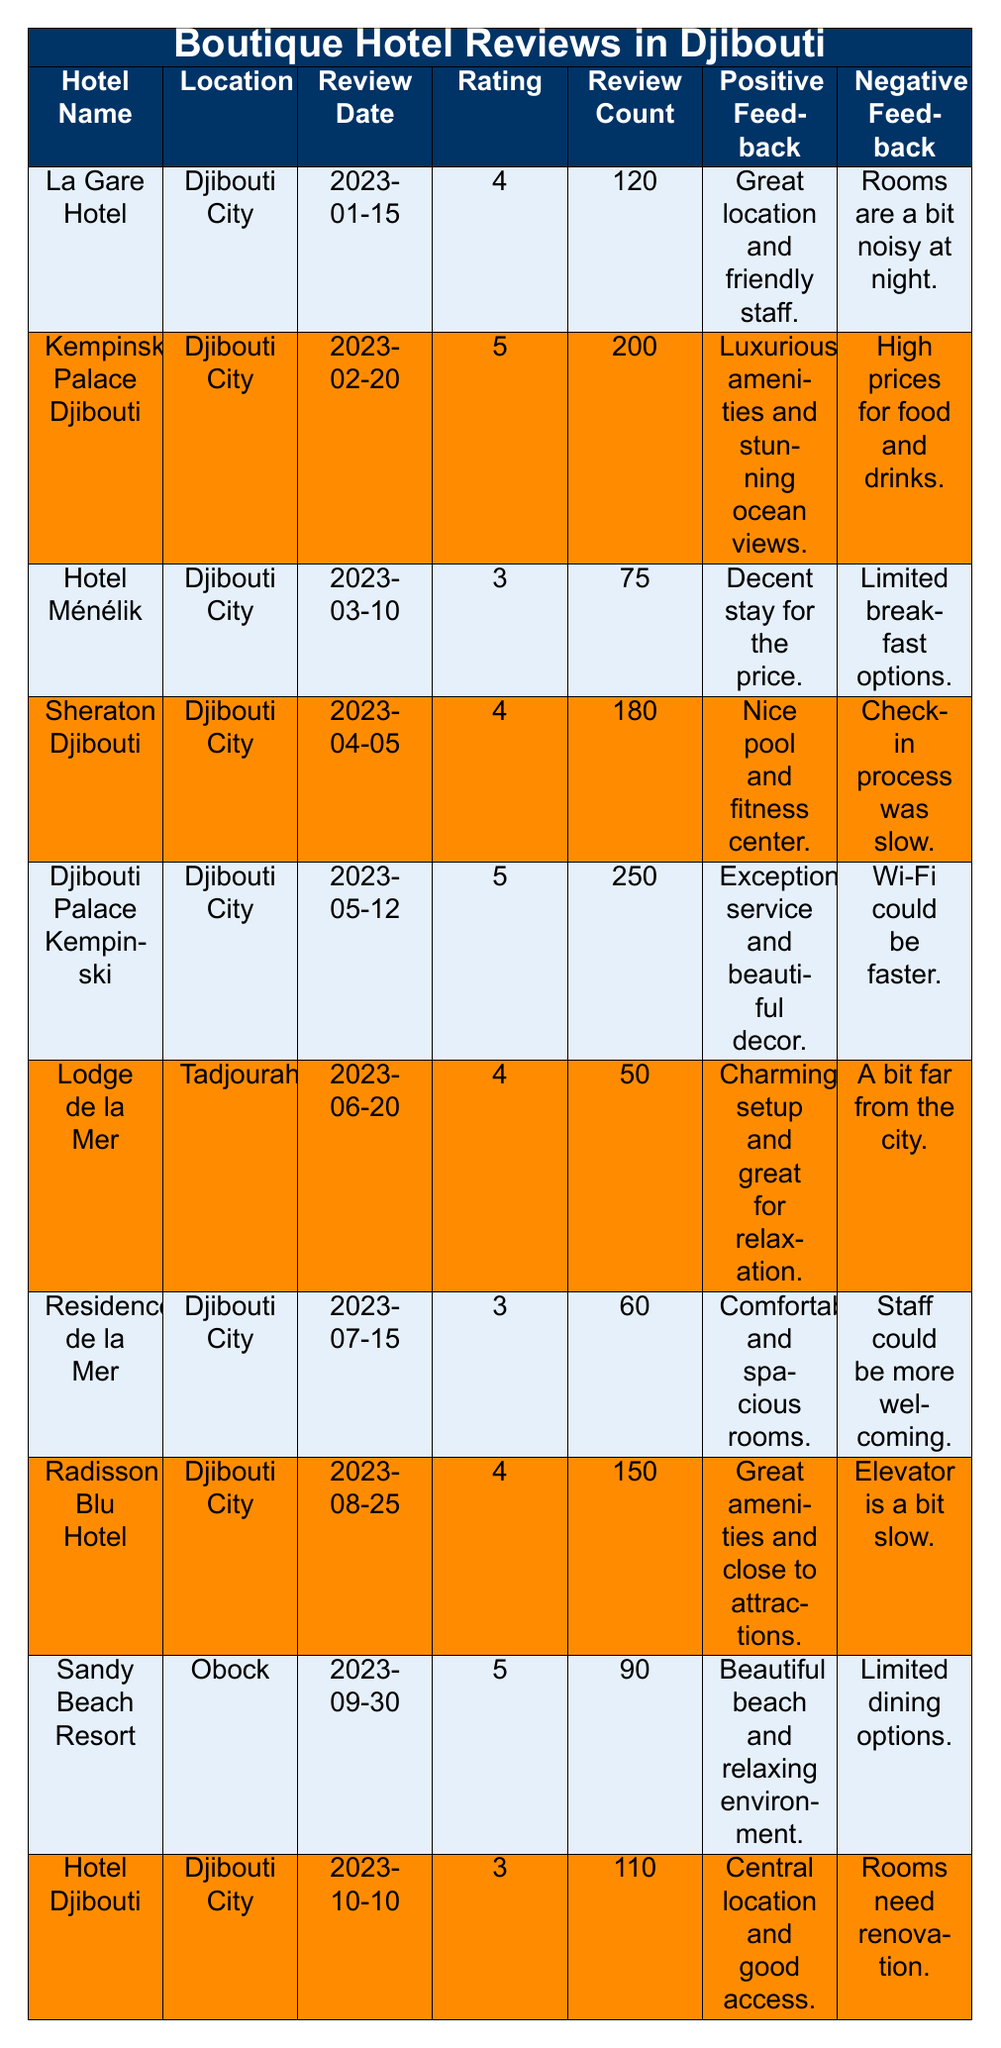What is the highest review rating among the hotels listed? The highest rating in the table is 5, which can be found next to "Kempinski Palace Djibouti", "Djibouti Palace Kempinski", and "Sandy Beach Resort".
Answer: 5 Which hotel received the most reviews? "Djibouti Palace Kempinski" has the highest review count of 250, as indicated in the review count column.
Answer: 250 How many hotels received a rating of 4? The hotels with a rating of 4 are "La Gare Hotel", "Sheraton Djibouti", "Lodge de la Mer", and "Radisson Blu Hotel", totaling 4 hotels.
Answer: 4 Which hotel has the most positive feedback regarding the quality of service? "Djibouti Palace Kempinski" mentions "Exceptional service and beautiful decor," making it the hotel with the best positive feedback about service.
Answer: Djibouti Palace Kempinski Is there a hotel that received a rating of 3? Yes, "Hotel Ménélik", "Residence de la Mer", and "Hotel Djibouti" each received a rating of 3.
Answer: Yes What is the average rating of all the hotels listed? The ratings are 4, 5, 3, 4, 5, 4, 3, 4, 5, 3, which sum up to 4. The total number of hotels is 10. Therefore, the average rating is (4 + 5 + 3 + 4 + 5 + 4 + 3 + 4 + 5 + 3) / 10 = 4.
Answer: 4 What negative feedback is common among the hotels? The common negative feedback includes "rooms need renovation" and "staff could be more welcoming," indicating general dissatisfaction with room conditions and staff service.
Answer: Renovation need and staff service Which hotel is located in Tadjourah, and what is its rating? "Lodge de la Mer" is located in Tadjourah and has a rating of 4, as seen under its location and rating columns.
Answer: Lodge de la Mer, 4 What is the total number of reviews across all hotels? By adding the review counts: 120 + 200 + 75 + 180 + 250 + 50 + 60 + 150 + 90 + 110 = 1,125.
Answer: 1125 How does the rating of the "Sheraton Djibouti" compare to "Hotel Ménélik"? "Sheraton Djibouti" has a rating of 4, while "Hotel Ménélik" has a rating of 3. Therefore, "Sheraton Djibouti" has a higher rating than "Hotel Ménélik".
Answer: Higher What percentage of hotels received a rating of 5 out of the total number of hotels? There are 3 hotels with a rating of 5 out of a total of 10 hotels. Thus, the percentage is (3/10) * 100 = 30%.
Answer: 30% 